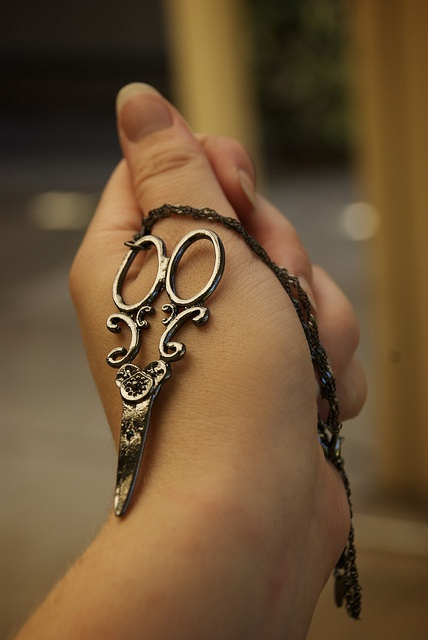Describe the objects in this image and their specific colors. I can see people in black, gray, maroon, tan, and brown tones and scissors in black, olive, tan, and maroon tones in this image. 